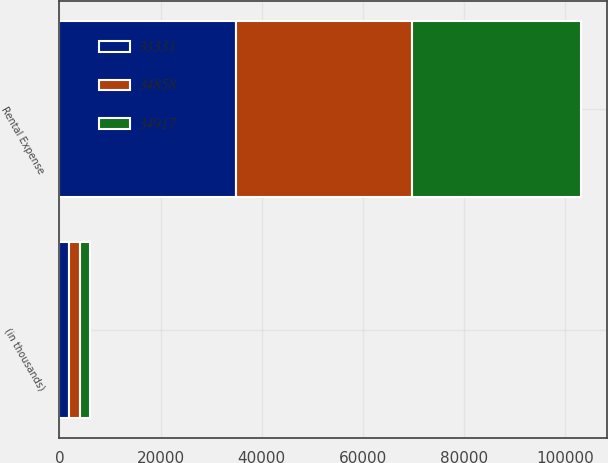<chart> <loc_0><loc_0><loc_500><loc_500><stacked_bar_chart><ecel><fcel>(in thousands)<fcel>Rental Expense<nl><fcel>34917<fcel>2007<fcel>33331<nl><fcel>33331<fcel>2006<fcel>34858<nl><fcel>34858<fcel>2005<fcel>34917<nl></chart> 